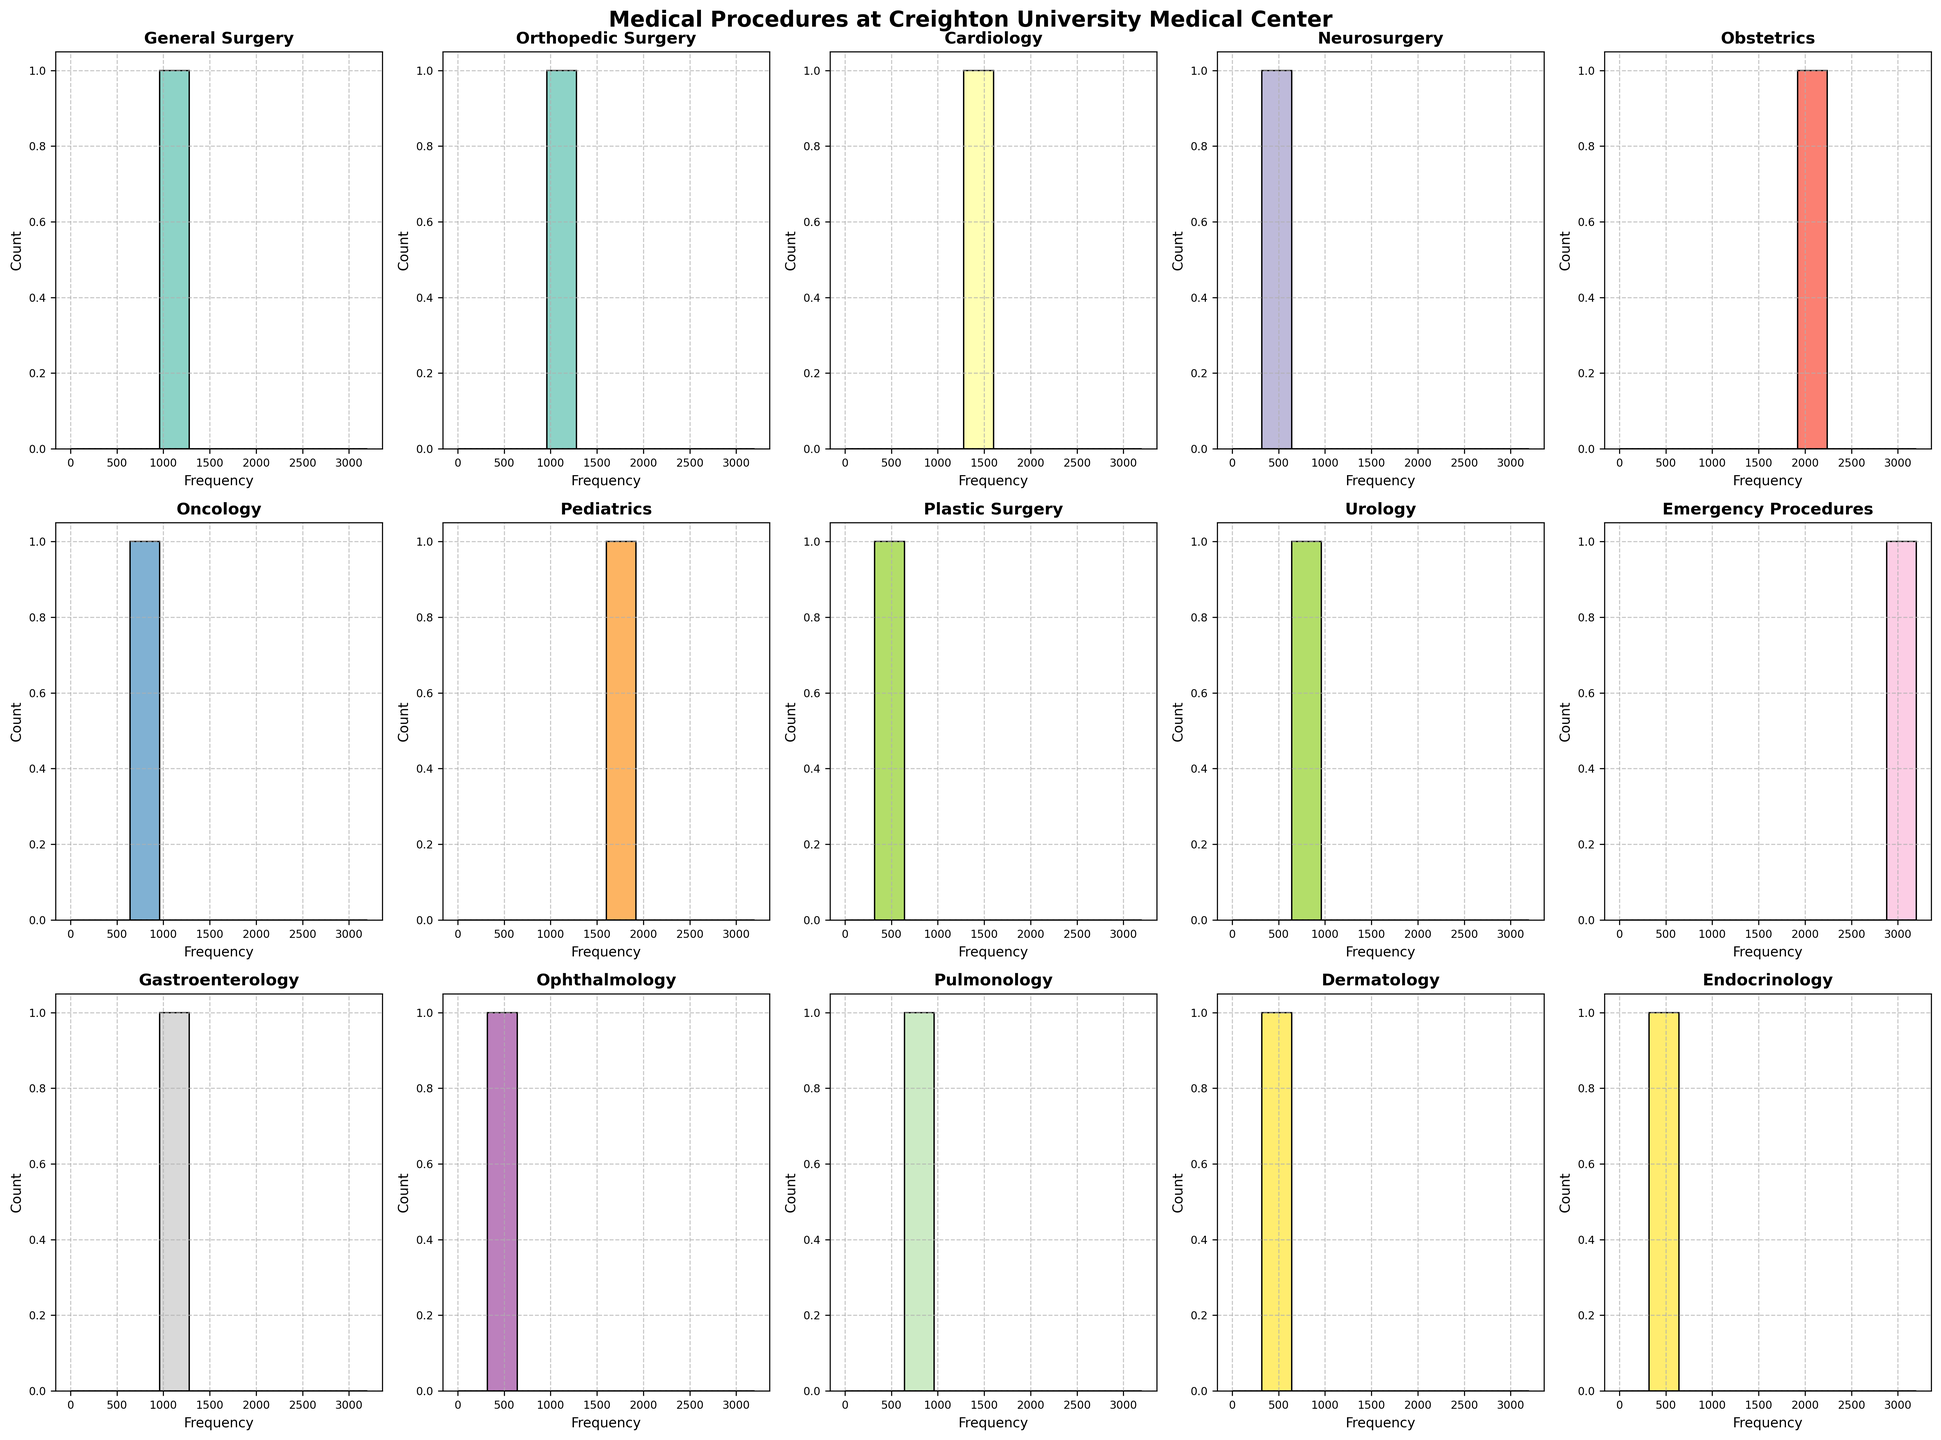What is the title of the figure? The title of the figure is located at the top of the plot. It is typically in bold and larger font size compared to the other text elements.
Answer: Medical Procedures at Creighton University Medical Center Which procedure has the highest frequency? Look at the histogram with the tallest bar. Each histogram title represents a different procedure, and the height of the bar directly corresponds to its frequency. The tallest bar is located at the "Emergency Procedures" subplot.
Answer: Emergency Procedures Which procedure has a frequency of 1450? Find the histogram where the bar reaches the frequency value of 1450 on the x-axis. The title of this histogram will tell you the procedure type. The histogram for "Cardiology" has a frequency bar at 1450.
Answer: Cardiology What is the combined frequency of General Surgery and Orthopedic Surgery? Locate the histograms for both "General Surgery" and "Orthopedic Surgery" and note their frequencies. Add the two frequencies together: 1250 (General Surgery) + 980 (Orthopedic Surgery) = 2230.
Answer: 2230 Which procedure has a frequency closest to 1000? Identify the histogram whose frequency bar is closest to 1000. By examining the heights of the bars, the "Gastroenterology" histogram has a frequency of 1100, which is the closest to 1000.
Answer: Gastroenterology What is the ratio of Obstetrics procedures to Pediatrics procedures? Find the frequencies of both "Obstetrics" and "Pediatrics" histograms, then divide the Obstetrics frequency by the Pediatrics frequency: 2100 (Obstetrics) / 1680 (Pediatrics) = 1.25.
Answer: 1.25 Which procedure has the lowest frequency, and what is its frequency? Scan through the histograms and identify the one with the smallest bar. The "Obstetrics" histogram has the lowest frequency, which is 210.
Answer: Obstetrics, 210 How many histograms have frequencies greater than 1000? Count the number of histograms where the frequency bars exceed 1000. The histograms for "General Surgery", "Cardiology", "Obstetrics", "Pediatrics", and "Emergency Procedures" all have frequencies greater than 1000.
Answer: 5 What is the frequency difference between Pulmonology and Dermatology procedures? Identify the frequencies of both the "Pulmonology" and "Dermatology" histograms and subtract the smaller frequency from the larger one: Pulmonology (780) - Dermatology (420) = 360.
Answer: 360 Which procedures have a frequency above the average frequency of all procedures? First, calculate the average frequency by summing all the frequencies and dividing by the number of procedures: (1250 + 980 + 1450 + 410 + 2100 + 890 + 1680 + 320 + 750 + 3200 + 1100 + 560 + 780 + 420 + 340) / 15 = 1197.3. Then identify the bins above this average: "General Surgery", "Cardiology", "Obstetrics", "Pediatrics", "Emergency Procedures", and "Gastroenterology".
Answer: General Surgery, Cardiology, Obstetrics, Pediatrics, Emergency Procedures, Gastroenterology 